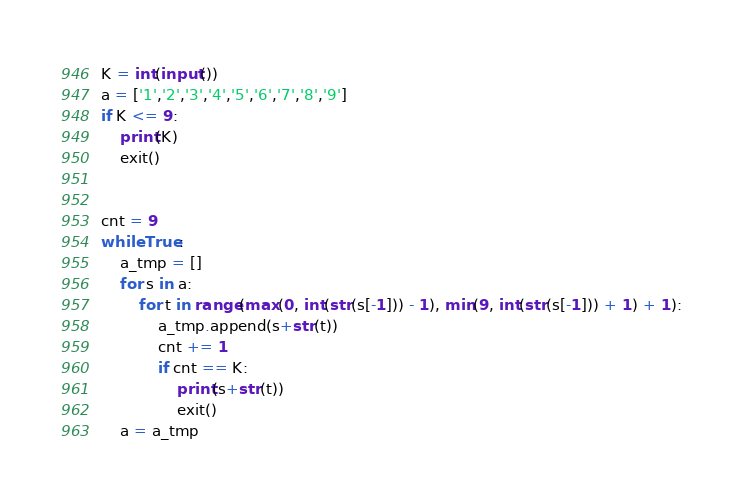<code> <loc_0><loc_0><loc_500><loc_500><_Python_>K = int(input())
a = ['1','2','3','4','5','6','7','8','9']
if K <= 9:
    print(K)
    exit()


cnt = 9
while True:
    a_tmp = []
    for s in a:
        for t in range(max(0, int(str(s[-1])) - 1), min(9, int(str(s[-1])) + 1) + 1):
            a_tmp.append(s+str(t))
            cnt += 1
            if cnt == K:
                print(s+str(t))
                exit()
    a = a_tmp


</code> 